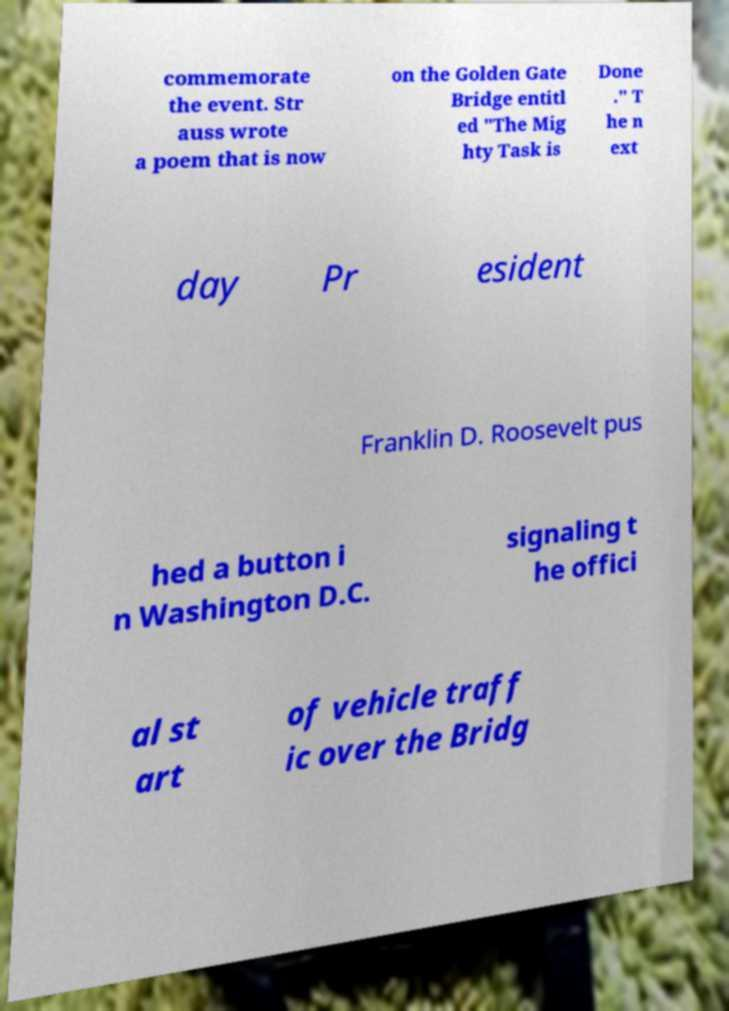Can you accurately transcribe the text from the provided image for me? commemorate the event. Str auss wrote a poem that is now on the Golden Gate Bridge entitl ed "The Mig hty Task is Done ." T he n ext day Pr esident Franklin D. Roosevelt pus hed a button i n Washington D.C. signaling t he offici al st art of vehicle traff ic over the Bridg 